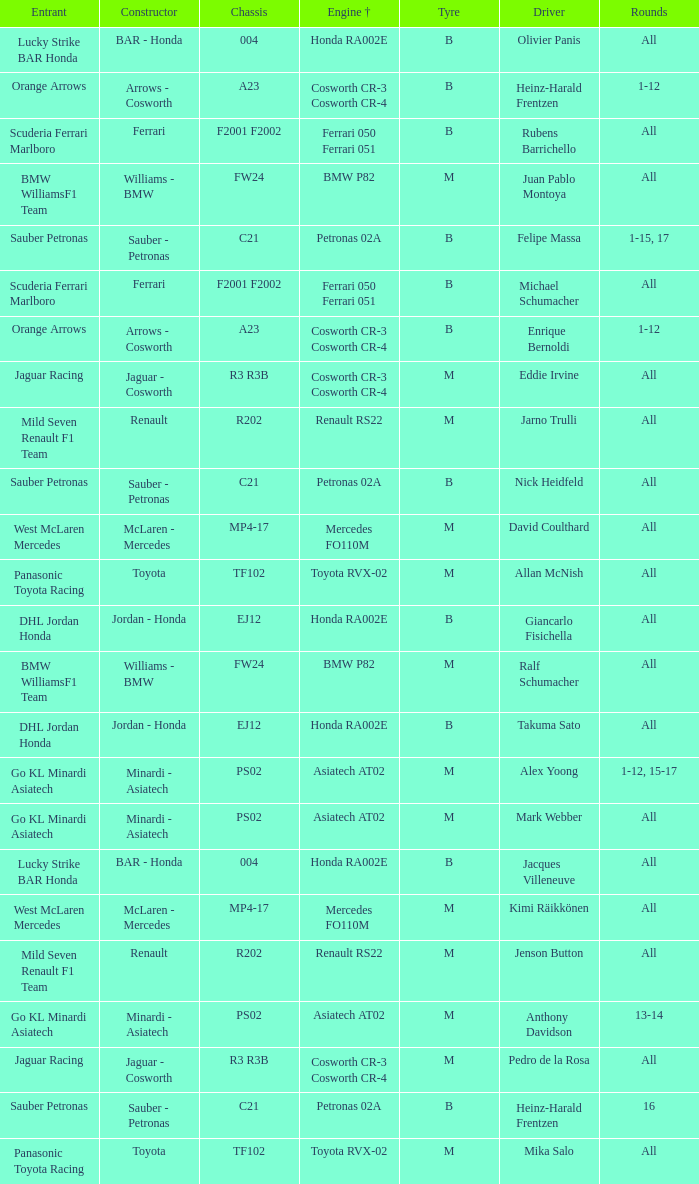Write the full table. {'header': ['Entrant', 'Constructor', 'Chassis', 'Engine †', 'Tyre', 'Driver', 'Rounds'], 'rows': [['Lucky Strike BAR Honda', 'BAR - Honda', '004', 'Honda RA002E', 'B', 'Olivier Panis', 'All'], ['Orange Arrows', 'Arrows - Cosworth', 'A23', 'Cosworth CR-3 Cosworth CR-4', 'B', 'Heinz-Harald Frentzen', '1-12'], ['Scuderia Ferrari Marlboro', 'Ferrari', 'F2001 F2002', 'Ferrari 050 Ferrari 051', 'B', 'Rubens Barrichello', 'All'], ['BMW WilliamsF1 Team', 'Williams - BMW', 'FW24', 'BMW P82', 'M', 'Juan Pablo Montoya', 'All'], ['Sauber Petronas', 'Sauber - Petronas', 'C21', 'Petronas 02A', 'B', 'Felipe Massa', '1-15, 17'], ['Scuderia Ferrari Marlboro', 'Ferrari', 'F2001 F2002', 'Ferrari 050 Ferrari 051', 'B', 'Michael Schumacher', 'All'], ['Orange Arrows', 'Arrows - Cosworth', 'A23', 'Cosworth CR-3 Cosworth CR-4', 'B', 'Enrique Bernoldi', '1-12'], ['Jaguar Racing', 'Jaguar - Cosworth', 'R3 R3B', 'Cosworth CR-3 Cosworth CR-4', 'M', 'Eddie Irvine', 'All'], ['Mild Seven Renault F1 Team', 'Renault', 'R202', 'Renault RS22', 'M', 'Jarno Trulli', 'All'], ['Sauber Petronas', 'Sauber - Petronas', 'C21', 'Petronas 02A', 'B', 'Nick Heidfeld', 'All'], ['West McLaren Mercedes', 'McLaren - Mercedes', 'MP4-17', 'Mercedes FO110M', 'M', 'David Coulthard', 'All'], ['Panasonic Toyota Racing', 'Toyota', 'TF102', 'Toyota RVX-02', 'M', 'Allan McNish', 'All'], ['DHL Jordan Honda', 'Jordan - Honda', 'EJ12', 'Honda RA002E', 'B', 'Giancarlo Fisichella', 'All'], ['BMW WilliamsF1 Team', 'Williams - BMW', 'FW24', 'BMW P82', 'M', 'Ralf Schumacher', 'All'], ['DHL Jordan Honda', 'Jordan - Honda', 'EJ12', 'Honda RA002E', 'B', 'Takuma Sato', 'All'], ['Go KL Minardi Asiatech', 'Minardi - Asiatech', 'PS02', 'Asiatech AT02', 'M', 'Alex Yoong', '1-12, 15-17'], ['Go KL Minardi Asiatech', 'Minardi - Asiatech', 'PS02', 'Asiatech AT02', 'M', 'Mark Webber', 'All'], ['Lucky Strike BAR Honda', 'BAR - Honda', '004', 'Honda RA002E', 'B', 'Jacques Villeneuve', 'All'], ['West McLaren Mercedes', 'McLaren - Mercedes', 'MP4-17', 'Mercedes FO110M', 'M', 'Kimi Räikkönen', 'All'], ['Mild Seven Renault F1 Team', 'Renault', 'R202', 'Renault RS22', 'M', 'Jenson Button', 'All'], ['Go KL Minardi Asiatech', 'Minardi - Asiatech', 'PS02', 'Asiatech AT02', 'M', 'Anthony Davidson', '13-14'], ['Jaguar Racing', 'Jaguar - Cosworth', 'R3 R3B', 'Cosworth CR-3 Cosworth CR-4', 'M', 'Pedro de la Rosa', 'All'], ['Sauber Petronas', 'Sauber - Petronas', 'C21', 'Petronas 02A', 'B', 'Heinz-Harald Frentzen', '16'], ['Panasonic Toyota Racing', 'Toyota', 'TF102', 'Toyota RVX-02', 'M', 'Mika Salo', 'All']]} What is the chassis when the tyre is b, the engine is ferrari 050 ferrari 051 and the driver is rubens barrichello? F2001 F2002. 